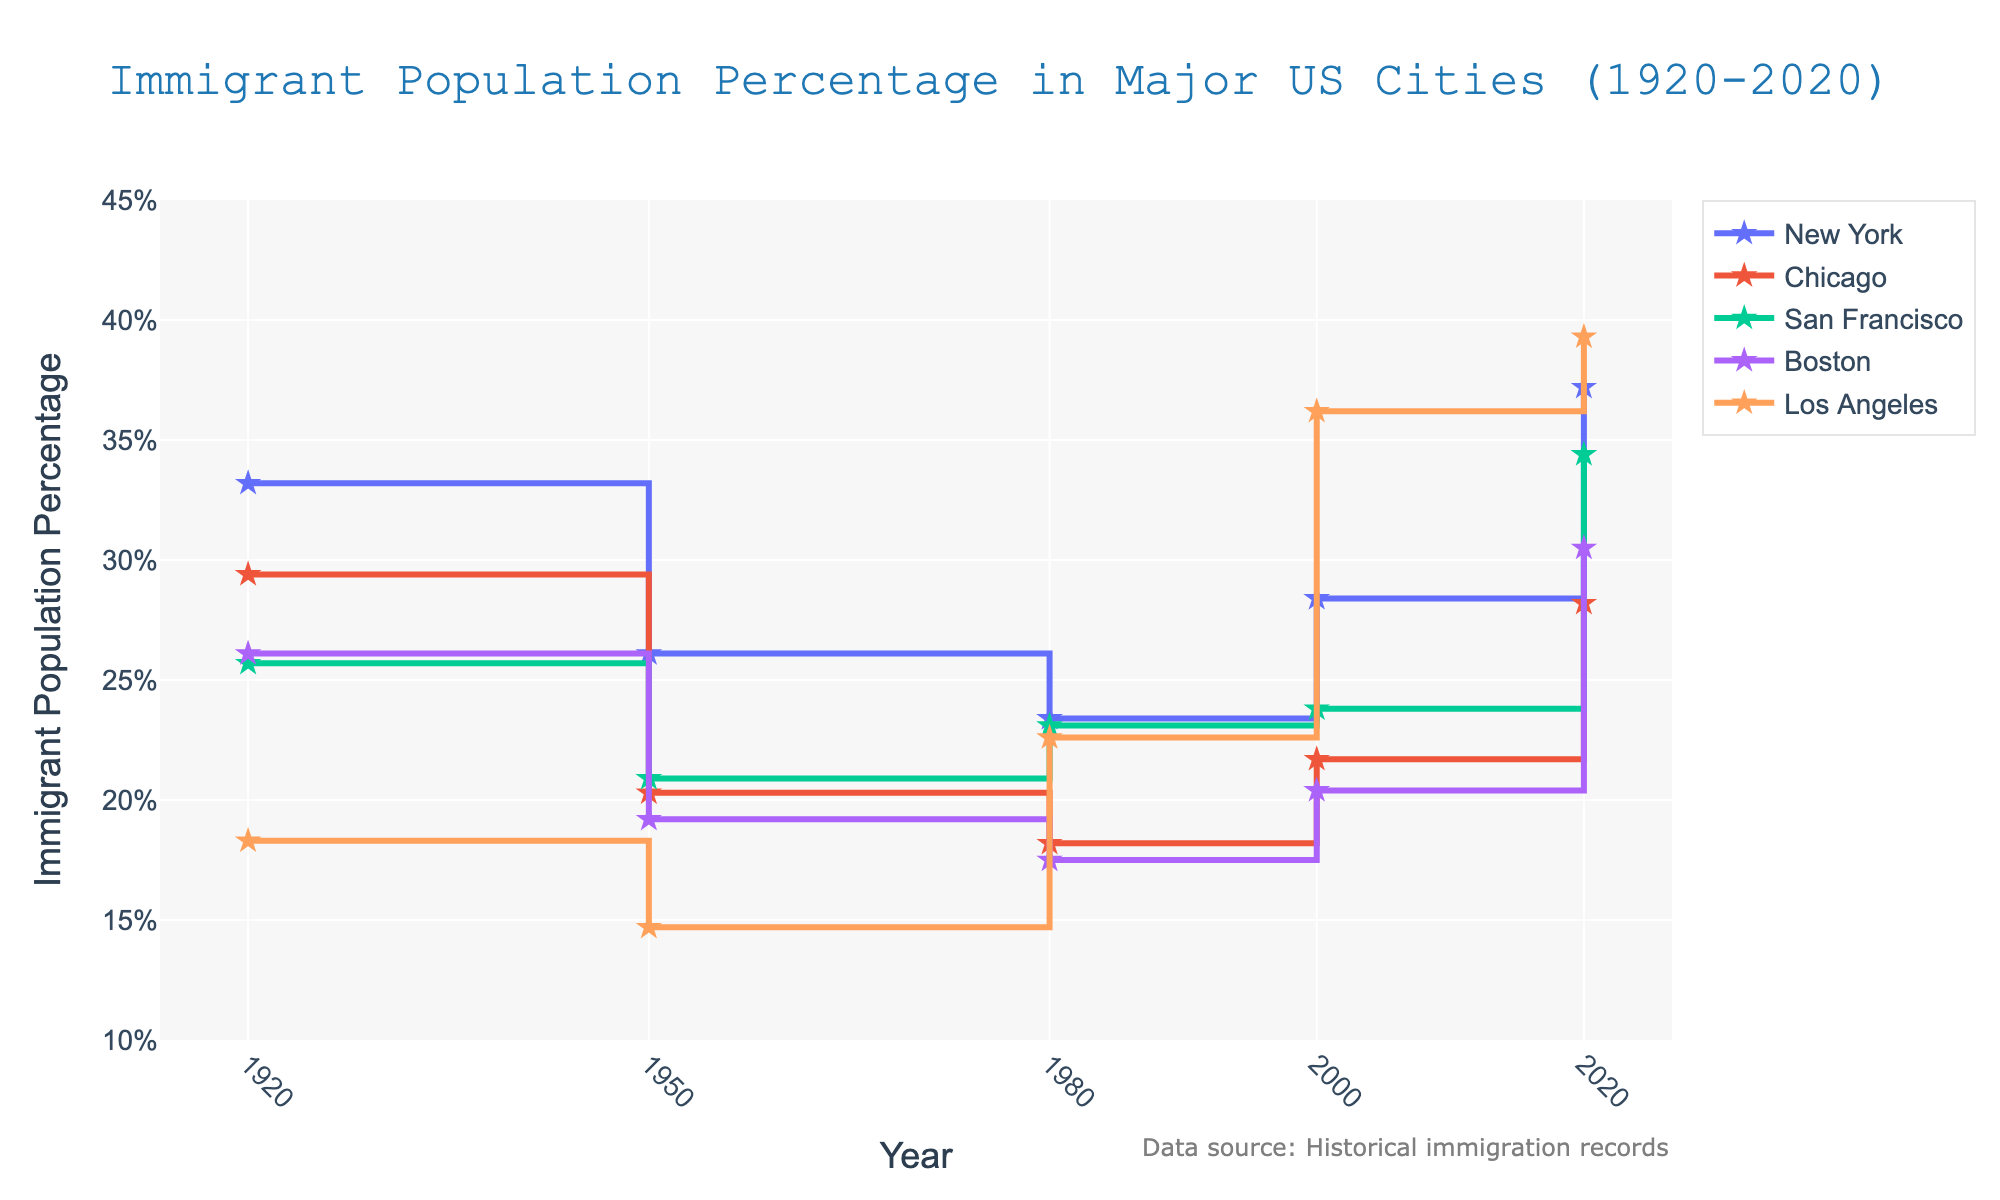What is the title of the figure? The title is displayed at the top of the figure. The title is 'Immigrant Population Percentage in Major US Cities (1920-2020)'
Answer: Immigrant Population Percentage in Major US Cities (1920-2020) Which city had the highest immigrant population percentage in 1920? Look at the data points for all cities in the year 1920. New York has the highest percentage at 33.2%
Answer: New York How did the immigrant population percentage in Los Angeles change from 1980 to 2000? In 1980, the percentage for Los Angeles was 22.6%, and in 2000, it was 36.2%. Subtract the percentage in 1980 from the percentage in 2000 to find the change: 36.2% - 22.6% = 13.6%
Answer: Increased by 13.6% Which city experienced the most significant increase in immigrant population percentage from 2000 to 2020? Compare the 2000 and 2020 data points for each city. Los Angeles increased from 36.2% to 39.3%, an increase of 3.1%, but New York increased from 28.4% to 37.2%, an increase of 8.8%. San Francisco increased from 23.8% to 34.4%, an increase of 10.6%. Boston increased from 20.4% to 30.5%, an increase of 10.1%. Thus, San Francisco had the highest increase
Answer: San Francisco What is the trend of the immigrant population percentage in Chicago from 1920 to 2020? Follow the data points for Chicago from 1920 to 2020: 29.4% in 1920, 20.3% in 1950, 18.2% in 1980, 21.7% in 2000, and 28.2% in 2020. The trend shows a decrease from 1920 to 1980, then an increase from 1980 to 2020
Answer: Decreasing until 1980, then increasing In which year did New York have the lowest immigrant population percentage? Compare the data points for New York across all years: 33.2% in 1920, 26.1% in 1950, 23.4% in 1980, 28.4% in 2000, and 37.2% in 2020. The lowest percentage is in 1980
Answer: 1980 What is the average immigrant population percentage of Boston across all the years? Add the percentages of all years for Boston: 26.1% (1920) + 19.2% (1950) + 17.5% (1980) + 20.4% (2000) + 30.5% (2020) = 113.7%. Divide by the number of years (5): 113.7 / 5 = 22.74%
Answer: 22.74% Which city shows the most consistent immigrant population percentage across the years, i.e., the least variation? Calculate the range (max - min) for each city's data points: New York (37.2 - 23.4 = 13.8), Chicago (29.4 - 18.2 = 11.2), San Francisco (34.4 - 20.9 = 13.5), Boston (30.5 - 17.5 = 13.0), and Los Angeles (39.3 - 14.7 = 24.6). Chicago has the least variation
Answer: Chicago What noticeable pattern can you identify in the figure about the immigrant population percentages in major US cities from 1920 to 2020? Observing the overall trends through the figure, there is a general pattern of decline in immigrant population percentages from 1920 to around 1980, followed by an increase up to 2020. In recent years, percentages have risen considerably
Answer: Decrease until 1980, increase thereafter 